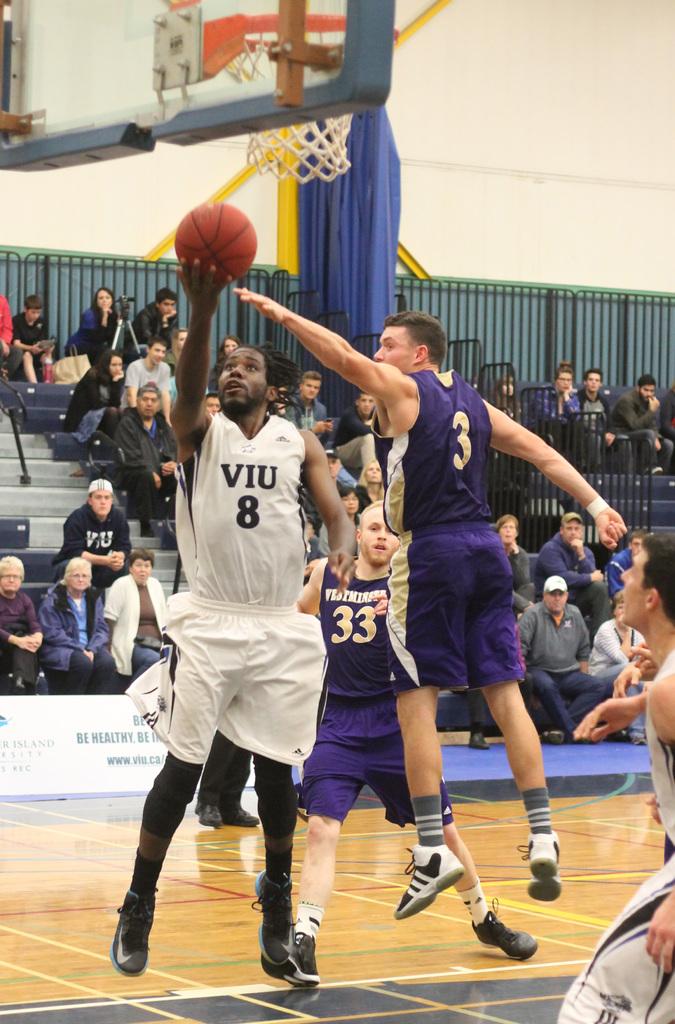What is the number on the white jersey?
Your answer should be very brief. 8. 